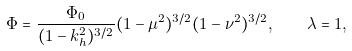<formula> <loc_0><loc_0><loc_500><loc_500>\Phi = \frac { \Phi _ { 0 } } { ( 1 - k _ { h } ^ { 2 } ) ^ { 3 / 2 } } ( 1 - \mu ^ { 2 } ) ^ { 3 / 2 } ( 1 - \nu ^ { 2 } ) ^ { 3 / 2 } , \quad \lambda = 1 ,</formula> 